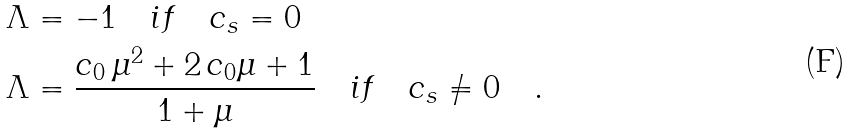<formula> <loc_0><loc_0><loc_500><loc_500>\Lambda & = - 1 \quad i f \quad c _ { s } = 0 \\ \Lambda & = \frac { c _ { 0 } \, \mu ^ { 2 } + 2 \, c _ { 0 } \mu + 1 } { 1 + \mu } \quad i f \quad c _ { s } \neq 0 \quad .</formula> 